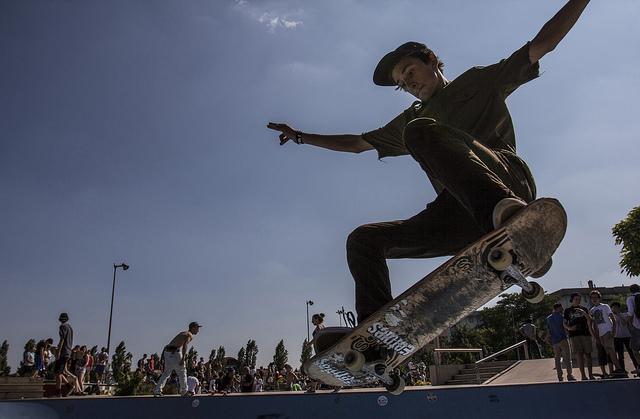Is this a pro skater?
Short answer required. Yes. Is he doing a trick?
Quick response, please. Yes. Is the guy on a skateboard?
Give a very brief answer. Yes. Would the area be lit at night?
Concise answer only. Yes. 